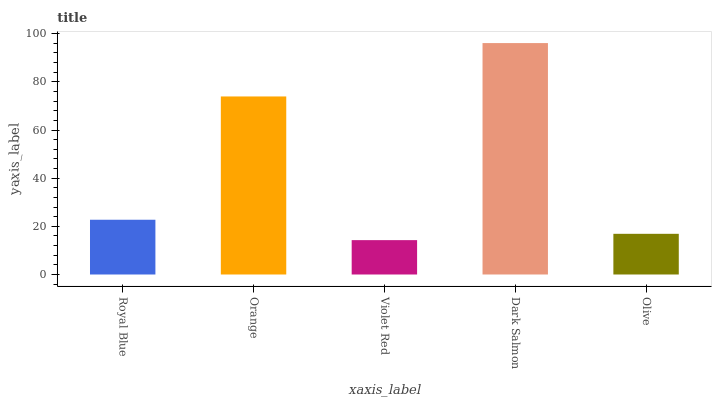Is Violet Red the minimum?
Answer yes or no. Yes. Is Dark Salmon the maximum?
Answer yes or no. Yes. Is Orange the minimum?
Answer yes or no. No. Is Orange the maximum?
Answer yes or no. No. Is Orange greater than Royal Blue?
Answer yes or no. Yes. Is Royal Blue less than Orange?
Answer yes or no. Yes. Is Royal Blue greater than Orange?
Answer yes or no. No. Is Orange less than Royal Blue?
Answer yes or no. No. Is Royal Blue the high median?
Answer yes or no. Yes. Is Royal Blue the low median?
Answer yes or no. Yes. Is Violet Red the high median?
Answer yes or no. No. Is Dark Salmon the low median?
Answer yes or no. No. 